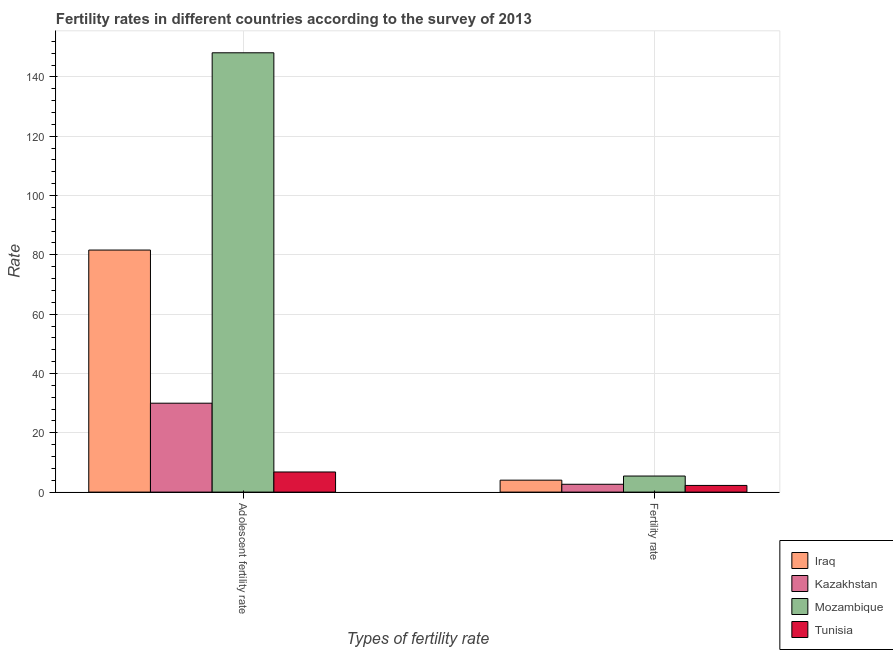How many groups of bars are there?
Provide a succinct answer. 2. Are the number of bars per tick equal to the number of legend labels?
Ensure brevity in your answer.  Yes. Are the number of bars on each tick of the X-axis equal?
Keep it short and to the point. Yes. What is the label of the 2nd group of bars from the left?
Give a very brief answer. Fertility rate. What is the adolescent fertility rate in Tunisia?
Make the answer very short. 6.79. Across all countries, what is the maximum adolescent fertility rate?
Make the answer very short. 148.14. Across all countries, what is the minimum adolescent fertility rate?
Ensure brevity in your answer.  6.79. In which country was the adolescent fertility rate maximum?
Your answer should be very brief. Mozambique. In which country was the adolescent fertility rate minimum?
Offer a very short reply. Tunisia. What is the total adolescent fertility rate in the graph?
Give a very brief answer. 266.53. What is the difference between the fertility rate in Kazakhstan and that in Tunisia?
Keep it short and to the point. 0.39. What is the difference between the adolescent fertility rate in Kazakhstan and the fertility rate in Tunisia?
Provide a short and direct response. 27.73. What is the average adolescent fertility rate per country?
Offer a very short reply. 66.63. What is the difference between the adolescent fertility rate and fertility rate in Tunisia?
Offer a very short reply. 4.54. What is the ratio of the adolescent fertility rate in Mozambique to that in Kazakhstan?
Make the answer very short. 4.94. In how many countries, is the adolescent fertility rate greater than the average adolescent fertility rate taken over all countries?
Provide a short and direct response. 2. What does the 3rd bar from the left in Fertility rate represents?
Your answer should be compact. Mozambique. What does the 3rd bar from the right in Adolescent fertility rate represents?
Offer a terse response. Kazakhstan. How many bars are there?
Provide a short and direct response. 8. Are all the bars in the graph horizontal?
Your answer should be compact. No. Does the graph contain any zero values?
Your answer should be compact. No. Does the graph contain grids?
Your answer should be very brief. Yes. Where does the legend appear in the graph?
Offer a very short reply. Bottom right. How are the legend labels stacked?
Your answer should be compact. Vertical. What is the title of the graph?
Give a very brief answer. Fertility rates in different countries according to the survey of 2013. Does "Afghanistan" appear as one of the legend labels in the graph?
Your response must be concise. No. What is the label or title of the X-axis?
Make the answer very short. Types of fertility rate. What is the label or title of the Y-axis?
Ensure brevity in your answer.  Rate. What is the Rate of Iraq in Adolescent fertility rate?
Keep it short and to the point. 81.62. What is the Rate in Kazakhstan in Adolescent fertility rate?
Offer a very short reply. 29.98. What is the Rate of Mozambique in Adolescent fertility rate?
Offer a very short reply. 148.14. What is the Rate in Tunisia in Adolescent fertility rate?
Give a very brief answer. 6.79. What is the Rate of Iraq in Fertility rate?
Give a very brief answer. 4.03. What is the Rate of Kazakhstan in Fertility rate?
Provide a succinct answer. 2.64. What is the Rate of Mozambique in Fertility rate?
Offer a very short reply. 5.42. What is the Rate of Tunisia in Fertility rate?
Give a very brief answer. 2.25. Across all Types of fertility rate, what is the maximum Rate of Iraq?
Offer a terse response. 81.62. Across all Types of fertility rate, what is the maximum Rate in Kazakhstan?
Ensure brevity in your answer.  29.98. Across all Types of fertility rate, what is the maximum Rate in Mozambique?
Provide a succinct answer. 148.14. Across all Types of fertility rate, what is the maximum Rate in Tunisia?
Offer a terse response. 6.79. Across all Types of fertility rate, what is the minimum Rate of Iraq?
Provide a succinct answer. 4.03. Across all Types of fertility rate, what is the minimum Rate in Kazakhstan?
Make the answer very short. 2.64. Across all Types of fertility rate, what is the minimum Rate in Mozambique?
Provide a short and direct response. 5.42. Across all Types of fertility rate, what is the minimum Rate in Tunisia?
Give a very brief answer. 2.25. What is the total Rate in Iraq in the graph?
Your response must be concise. 85.64. What is the total Rate in Kazakhstan in the graph?
Give a very brief answer. 32.62. What is the total Rate of Mozambique in the graph?
Make the answer very short. 153.56. What is the total Rate of Tunisia in the graph?
Make the answer very short. 9.04. What is the difference between the Rate in Iraq in Adolescent fertility rate and that in Fertility rate?
Keep it short and to the point. 77.59. What is the difference between the Rate of Kazakhstan in Adolescent fertility rate and that in Fertility rate?
Provide a succinct answer. 27.34. What is the difference between the Rate in Mozambique in Adolescent fertility rate and that in Fertility rate?
Offer a very short reply. 142.72. What is the difference between the Rate in Tunisia in Adolescent fertility rate and that in Fertility rate?
Give a very brief answer. 4.54. What is the difference between the Rate of Iraq in Adolescent fertility rate and the Rate of Kazakhstan in Fertility rate?
Your response must be concise. 78.98. What is the difference between the Rate in Iraq in Adolescent fertility rate and the Rate in Mozambique in Fertility rate?
Make the answer very short. 76.2. What is the difference between the Rate of Iraq in Adolescent fertility rate and the Rate of Tunisia in Fertility rate?
Make the answer very short. 79.37. What is the difference between the Rate of Kazakhstan in Adolescent fertility rate and the Rate of Mozambique in Fertility rate?
Offer a very short reply. 24.56. What is the difference between the Rate of Kazakhstan in Adolescent fertility rate and the Rate of Tunisia in Fertility rate?
Your answer should be compact. 27.73. What is the difference between the Rate of Mozambique in Adolescent fertility rate and the Rate of Tunisia in Fertility rate?
Offer a very short reply. 145.89. What is the average Rate of Iraq per Types of fertility rate?
Give a very brief answer. 42.82. What is the average Rate of Kazakhstan per Types of fertility rate?
Provide a succinct answer. 16.31. What is the average Rate in Mozambique per Types of fertility rate?
Ensure brevity in your answer.  76.78. What is the average Rate in Tunisia per Types of fertility rate?
Keep it short and to the point. 4.52. What is the difference between the Rate in Iraq and Rate in Kazakhstan in Adolescent fertility rate?
Offer a terse response. 51.64. What is the difference between the Rate in Iraq and Rate in Mozambique in Adolescent fertility rate?
Offer a very short reply. -66.52. What is the difference between the Rate in Iraq and Rate in Tunisia in Adolescent fertility rate?
Give a very brief answer. 74.83. What is the difference between the Rate of Kazakhstan and Rate of Mozambique in Adolescent fertility rate?
Provide a short and direct response. -118.16. What is the difference between the Rate in Kazakhstan and Rate in Tunisia in Adolescent fertility rate?
Provide a short and direct response. 23.19. What is the difference between the Rate of Mozambique and Rate of Tunisia in Adolescent fertility rate?
Make the answer very short. 141.35. What is the difference between the Rate in Iraq and Rate in Kazakhstan in Fertility rate?
Provide a short and direct response. 1.39. What is the difference between the Rate of Iraq and Rate of Mozambique in Fertility rate?
Give a very brief answer. -1.39. What is the difference between the Rate of Iraq and Rate of Tunisia in Fertility rate?
Offer a very short reply. 1.78. What is the difference between the Rate of Kazakhstan and Rate of Mozambique in Fertility rate?
Offer a very short reply. -2.78. What is the difference between the Rate in Kazakhstan and Rate in Tunisia in Fertility rate?
Offer a terse response. 0.39. What is the difference between the Rate in Mozambique and Rate in Tunisia in Fertility rate?
Your response must be concise. 3.17. What is the ratio of the Rate of Iraq in Adolescent fertility rate to that in Fertility rate?
Keep it short and to the point. 20.27. What is the ratio of the Rate in Kazakhstan in Adolescent fertility rate to that in Fertility rate?
Keep it short and to the point. 11.36. What is the ratio of the Rate of Mozambique in Adolescent fertility rate to that in Fertility rate?
Offer a terse response. 27.34. What is the ratio of the Rate in Tunisia in Adolescent fertility rate to that in Fertility rate?
Offer a very short reply. 3.02. What is the difference between the highest and the second highest Rate in Iraq?
Your answer should be very brief. 77.59. What is the difference between the highest and the second highest Rate in Kazakhstan?
Ensure brevity in your answer.  27.34. What is the difference between the highest and the second highest Rate in Mozambique?
Your answer should be very brief. 142.72. What is the difference between the highest and the second highest Rate of Tunisia?
Offer a terse response. 4.54. What is the difference between the highest and the lowest Rate in Iraq?
Keep it short and to the point. 77.59. What is the difference between the highest and the lowest Rate in Kazakhstan?
Offer a terse response. 27.34. What is the difference between the highest and the lowest Rate of Mozambique?
Your answer should be compact. 142.72. What is the difference between the highest and the lowest Rate of Tunisia?
Make the answer very short. 4.54. 